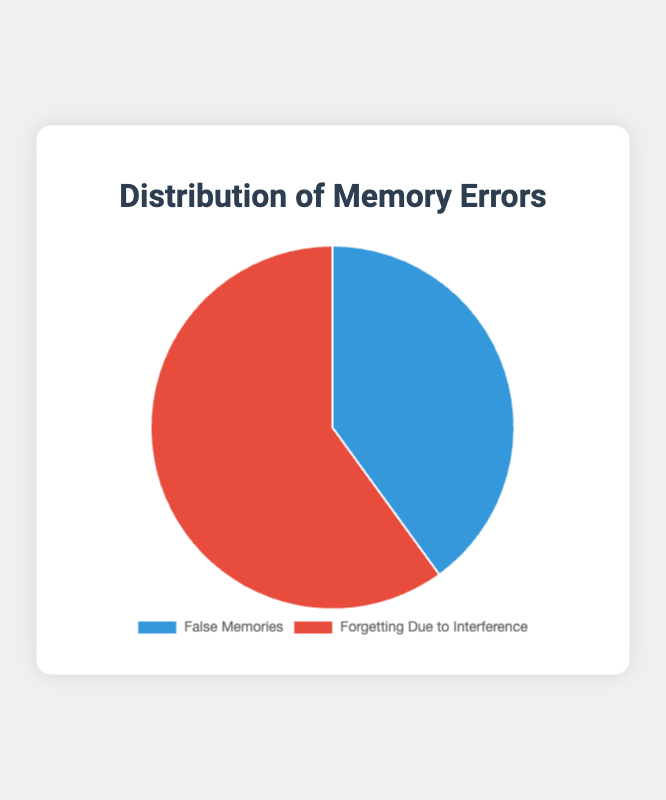What percentage of memory errors are due to false memories? The pie chart shows two categories of memory errors: False Memories and Forgetting Due to Interference. By observing the chart, it indicates that 40% of memory errors are due to false memories.
Answer: 40% What percentage of memory errors are due to forgetting due to interference? The pie chart shows two categories of memory errors: False Memories and Forgetting Due to Interference. By observing the chart, it indicates that 60% of memory errors are due to forgetting due to interference.
Answer: 60% Which type of memory error occurs more frequently? The chart compares two types of memory errors: False Memories and Forgetting Due to Interference. By observing that Forgetting Due to Interference takes up 60% while False Memories accounts for 40%, we can conclude that Forgetting Due to Interference is more frequent.
Answer: Forgetting Due to Interference What is the difference in percentage between the two types of memory errors? To determine the difference, subtract the percentage of False Memories (40%) from the percentage of Forgetting Due to Interference (60%). This gives us 60% - 40% = 20%.
Answer: 20% What is the total percentage represented by both types of memory errors? A pie chart represents the whole as 100%. Since the chart shows only two categories and they are complementary, the sum of their percentages is 100%. Therefore, 40% + 60% = 100%.
Answer: 100% What is the ratio of false memories to forgetting due to interference? The ratio is derived by comparing the percentages: 40% False Memories and 60% Forgetting Due to Interference. Therefore, the ratio is 40:60, which simplifies to 2:3.
Answer: 2:3 What is the percentage of memory errors due to interference relative to all errors? By referring to the chart, we can see Forgetting Due to Interference occupies 60% of memory errors. As the whole chart represents all memory errors (100%), interference errors are 60% relative to the total.
Answer: 60% If the data was collected from 200 memory error instances, how many instances were false memories? First, we need to calculate the actual number of instances corresponding to the 40% labeled as False Memories from the pie chart. This is done by taking 40% of 200, which is 0.4 * 200 = 80.
Answer: 80 What color represents the section for false memories in the pie chart? By observing the pie chart, the False Memories section is shown in blue.
Answer: Blue 